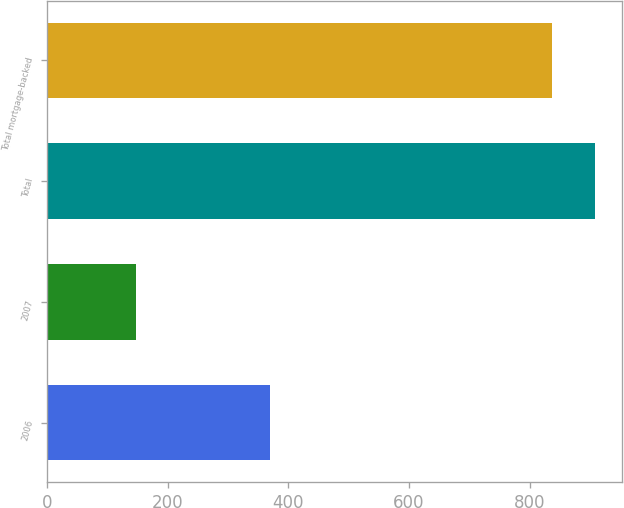Convert chart. <chart><loc_0><loc_0><loc_500><loc_500><bar_chart><fcel>2006<fcel>2007<fcel>Total<fcel>Total mortgage-backed<nl><fcel>369<fcel>147<fcel>907.5<fcel>836<nl></chart> 